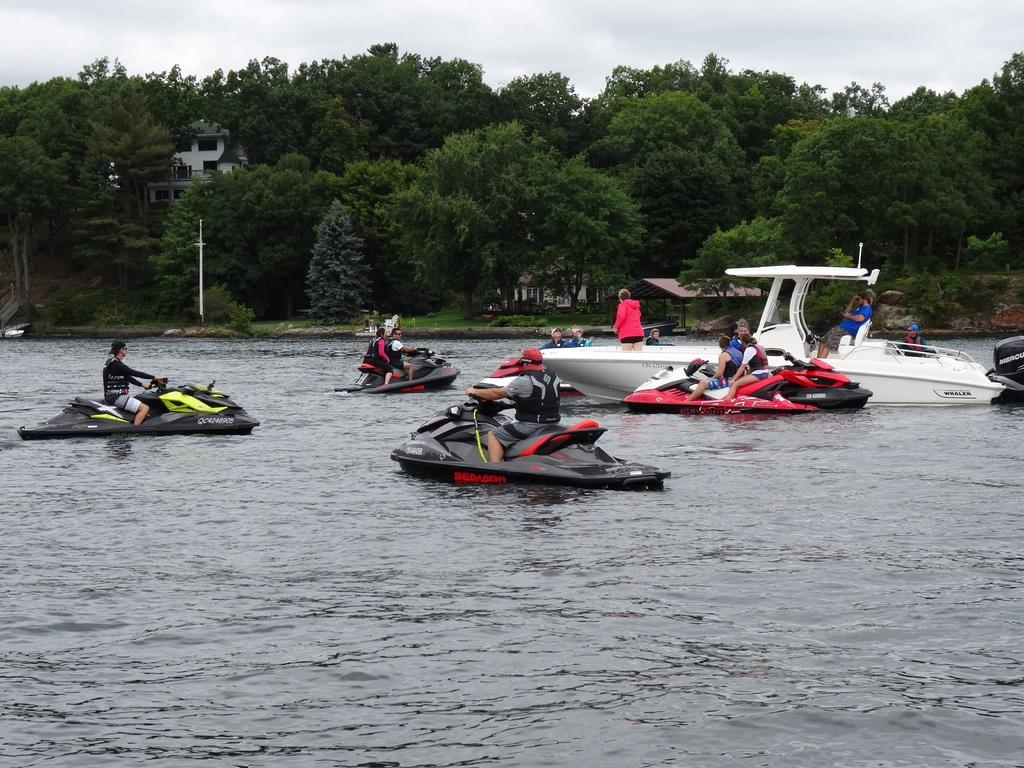What are the people in the image doing? The people in the image are in boats. What is the primary setting of the image? There is water visible in the image. What type of vegetation can be seen in the image? There are trees in the image. What structures are present in the image? There is a house, a shed, and a building in the image. What is visible in the background of the image? The sky is visible in the background of the image. Where is the mailbox located in the image? There is no mailbox present in the image. What type of scissors can be seen being used by the people in the boats? There are no scissors visible in the image, and the people in the boats are not using any. 